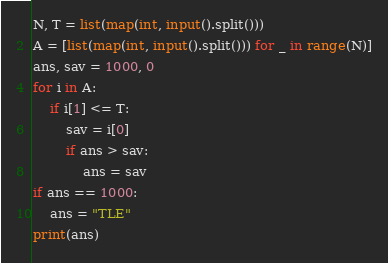Convert code to text. <code><loc_0><loc_0><loc_500><loc_500><_Python_>N, T = list(map(int, input().split()))
A = [list(map(int, input().split())) for _ in range(N)]
ans, sav = 1000, 0
for i in A:
    if i[1] <= T:
        sav = i[0]
        if ans > sav:
            ans = sav
if ans == 1000:
    ans = "TLE"
print(ans)</code> 